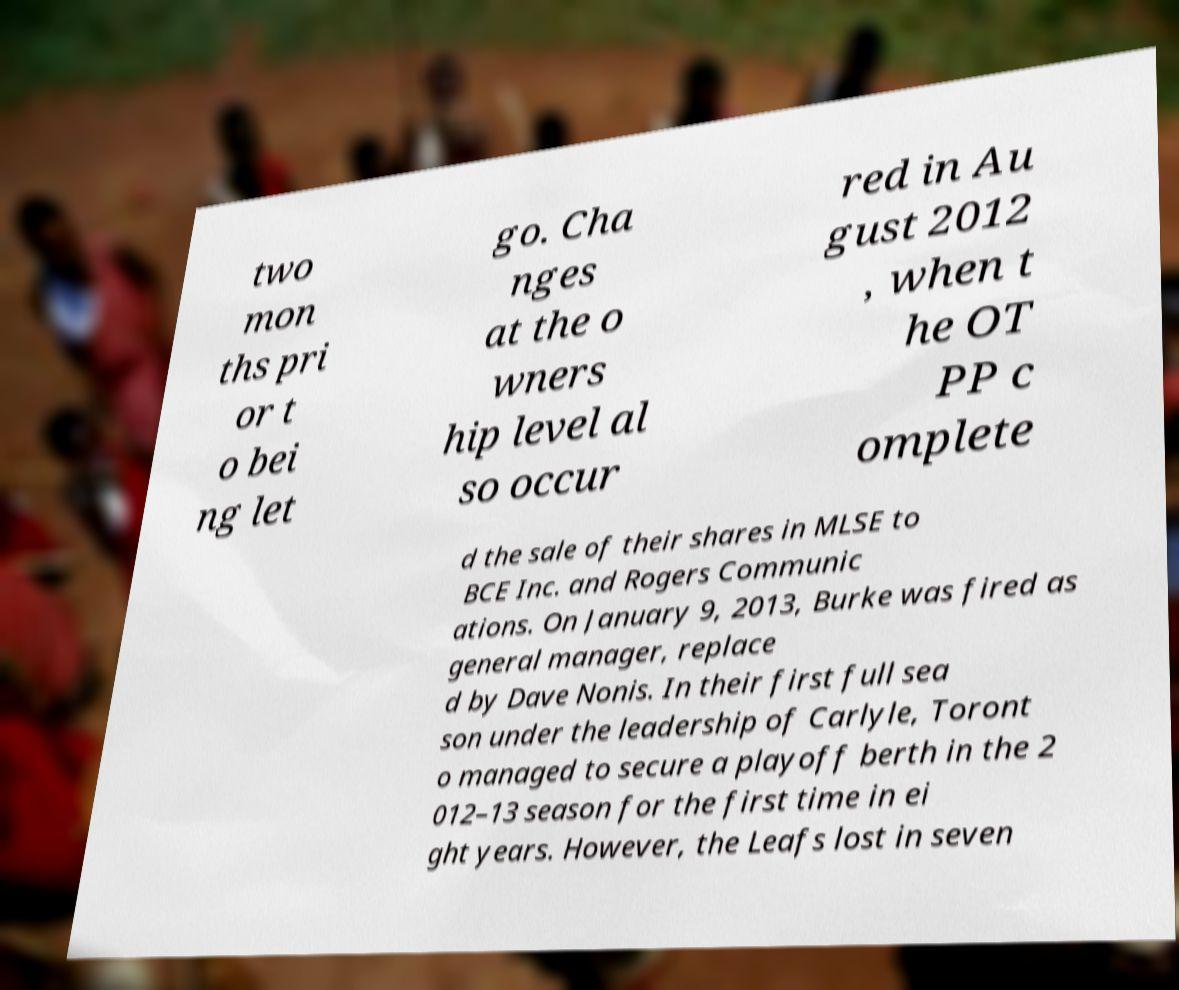What messages or text are displayed in this image? I need them in a readable, typed format. two mon ths pri or t o bei ng let go. Cha nges at the o wners hip level al so occur red in Au gust 2012 , when t he OT PP c omplete d the sale of their shares in MLSE to BCE Inc. and Rogers Communic ations. On January 9, 2013, Burke was fired as general manager, replace d by Dave Nonis. In their first full sea son under the leadership of Carlyle, Toront o managed to secure a playoff berth in the 2 012–13 season for the first time in ei ght years. However, the Leafs lost in seven 